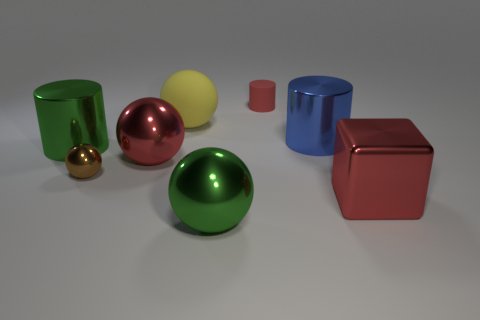Subtract all metallic balls. How many balls are left? 1 Subtract 1 cylinders. How many cylinders are left? 2 Subtract all blue cylinders. How many cylinders are left? 2 Subtract 0 cyan cubes. How many objects are left? 8 Subtract all cylinders. How many objects are left? 5 Subtract all cyan cubes. Subtract all red cylinders. How many cubes are left? 1 Subtract all green cylinders. How many brown balls are left? 1 Subtract all small matte things. Subtract all large shiny objects. How many objects are left? 2 Add 6 cubes. How many cubes are left? 7 Add 4 tiny red metal balls. How many tiny red metal balls exist? 4 